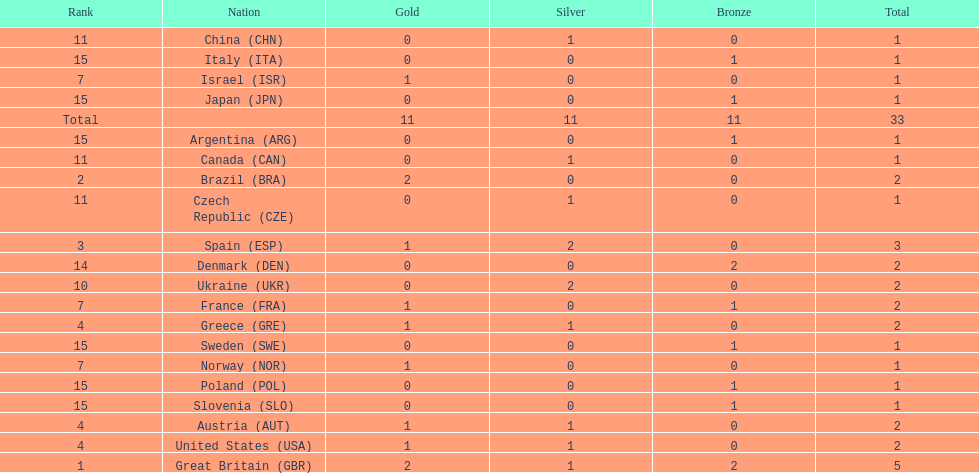Which nation was the only one to receive 3 medals? Spain (ESP). 